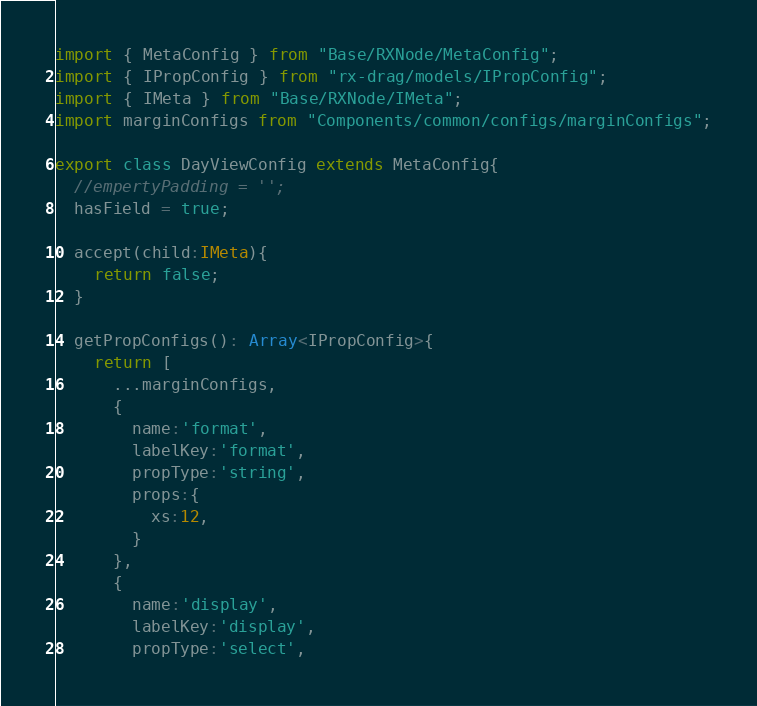Convert code to text. <code><loc_0><loc_0><loc_500><loc_500><_TypeScript_>import { MetaConfig } from "Base/RXNode/MetaConfig";
import { IPropConfig } from "rx-drag/models/IPropConfig";
import { IMeta } from "Base/RXNode/IMeta";
import marginConfigs from "Components/common/configs/marginConfigs";

export class DayViewConfig extends MetaConfig{
  //empertyPadding = '';
  hasField = true;
  
  accept(child:IMeta){
    return false;
  }

  getPropConfigs(): Array<IPropConfig>{
    return [
      ...marginConfigs,
      {
        name:'format',
        labelKey:'format',
        propType:'string',
        props:{
          xs:12,
        }
      },
      {
        name:'display',
        labelKey:'display',
        propType:'select',</code> 